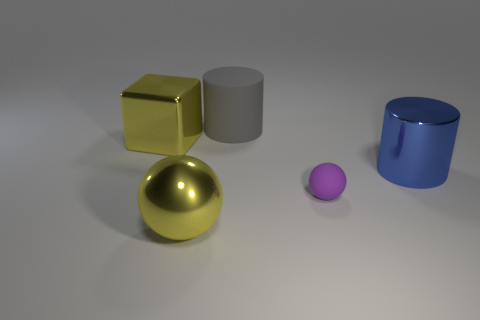Add 3 metal cylinders. How many objects exist? 8 Subtract all balls. How many objects are left? 3 Subtract all cyan cylinders. Subtract all brown balls. How many cylinders are left? 2 Add 4 large blue cylinders. How many large blue cylinders are left? 5 Add 2 big blue metal cylinders. How many big blue metal cylinders exist? 3 Subtract 1 purple spheres. How many objects are left? 4 Subtract all large gray objects. Subtract all large gray objects. How many objects are left? 3 